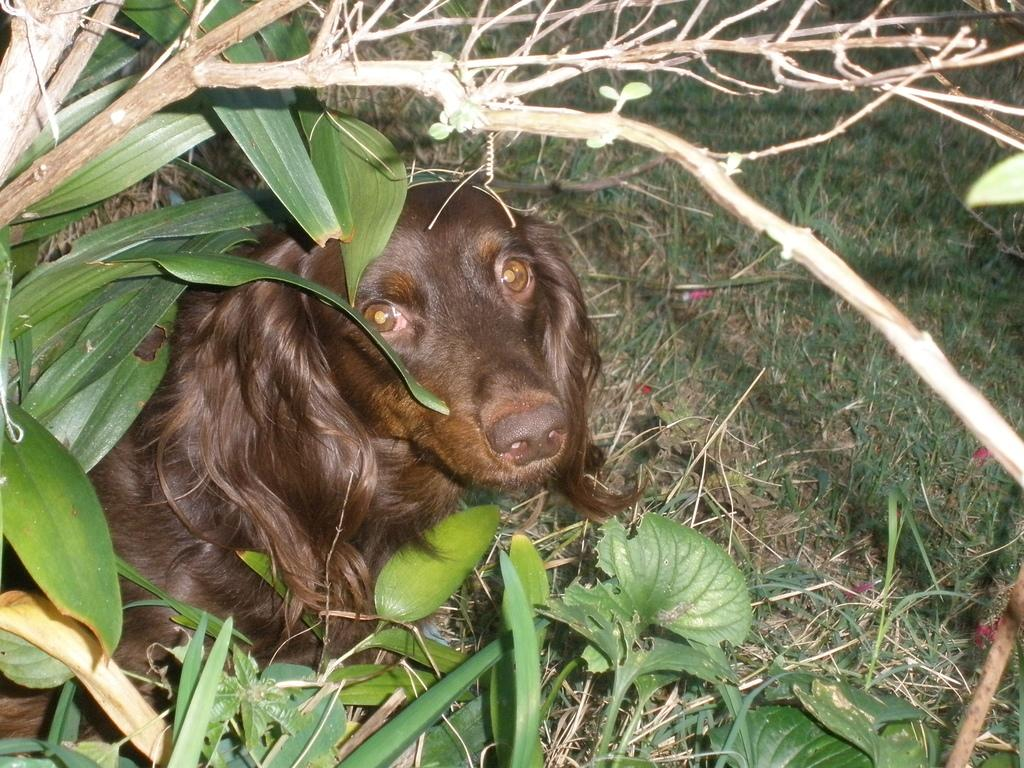What type of animal is in the image? There is a dog in the image. What color is the dog? The dog is black in color. What type of vegetation is present in the image? There is grass, a tree with branches and leaves, and small plants in the image. What type of brush is the actor using in the image? There is no actor or brush present in the image; it features a dog and various types of vegetation. 